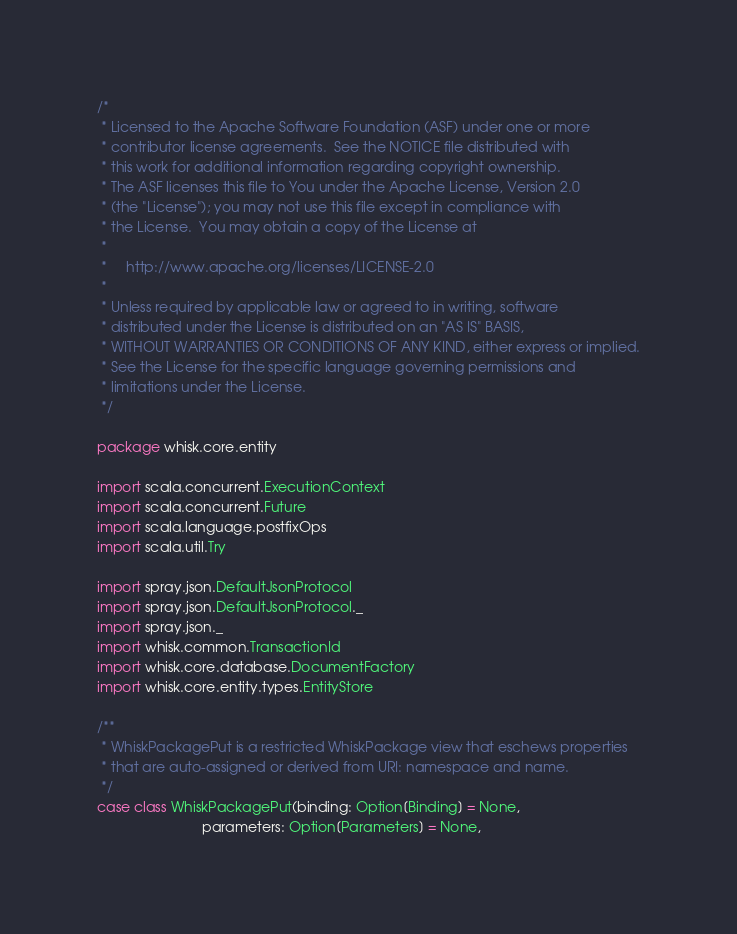<code> <loc_0><loc_0><loc_500><loc_500><_Scala_>/*
 * Licensed to the Apache Software Foundation (ASF) under one or more
 * contributor license agreements.  See the NOTICE file distributed with
 * this work for additional information regarding copyright ownership.
 * The ASF licenses this file to You under the Apache License, Version 2.0
 * (the "License"); you may not use this file except in compliance with
 * the License.  You may obtain a copy of the License at
 *
 *     http://www.apache.org/licenses/LICENSE-2.0
 *
 * Unless required by applicable law or agreed to in writing, software
 * distributed under the License is distributed on an "AS IS" BASIS,
 * WITHOUT WARRANTIES OR CONDITIONS OF ANY KIND, either express or implied.
 * See the License for the specific language governing permissions and
 * limitations under the License.
 */

package whisk.core.entity

import scala.concurrent.ExecutionContext
import scala.concurrent.Future
import scala.language.postfixOps
import scala.util.Try

import spray.json.DefaultJsonProtocol
import spray.json.DefaultJsonProtocol._
import spray.json._
import whisk.common.TransactionId
import whisk.core.database.DocumentFactory
import whisk.core.entity.types.EntityStore

/**
 * WhiskPackagePut is a restricted WhiskPackage view that eschews properties
 * that are auto-assigned or derived from URI: namespace and name.
 */
case class WhiskPackagePut(binding: Option[Binding] = None,
                           parameters: Option[Parameters] = None,</code> 